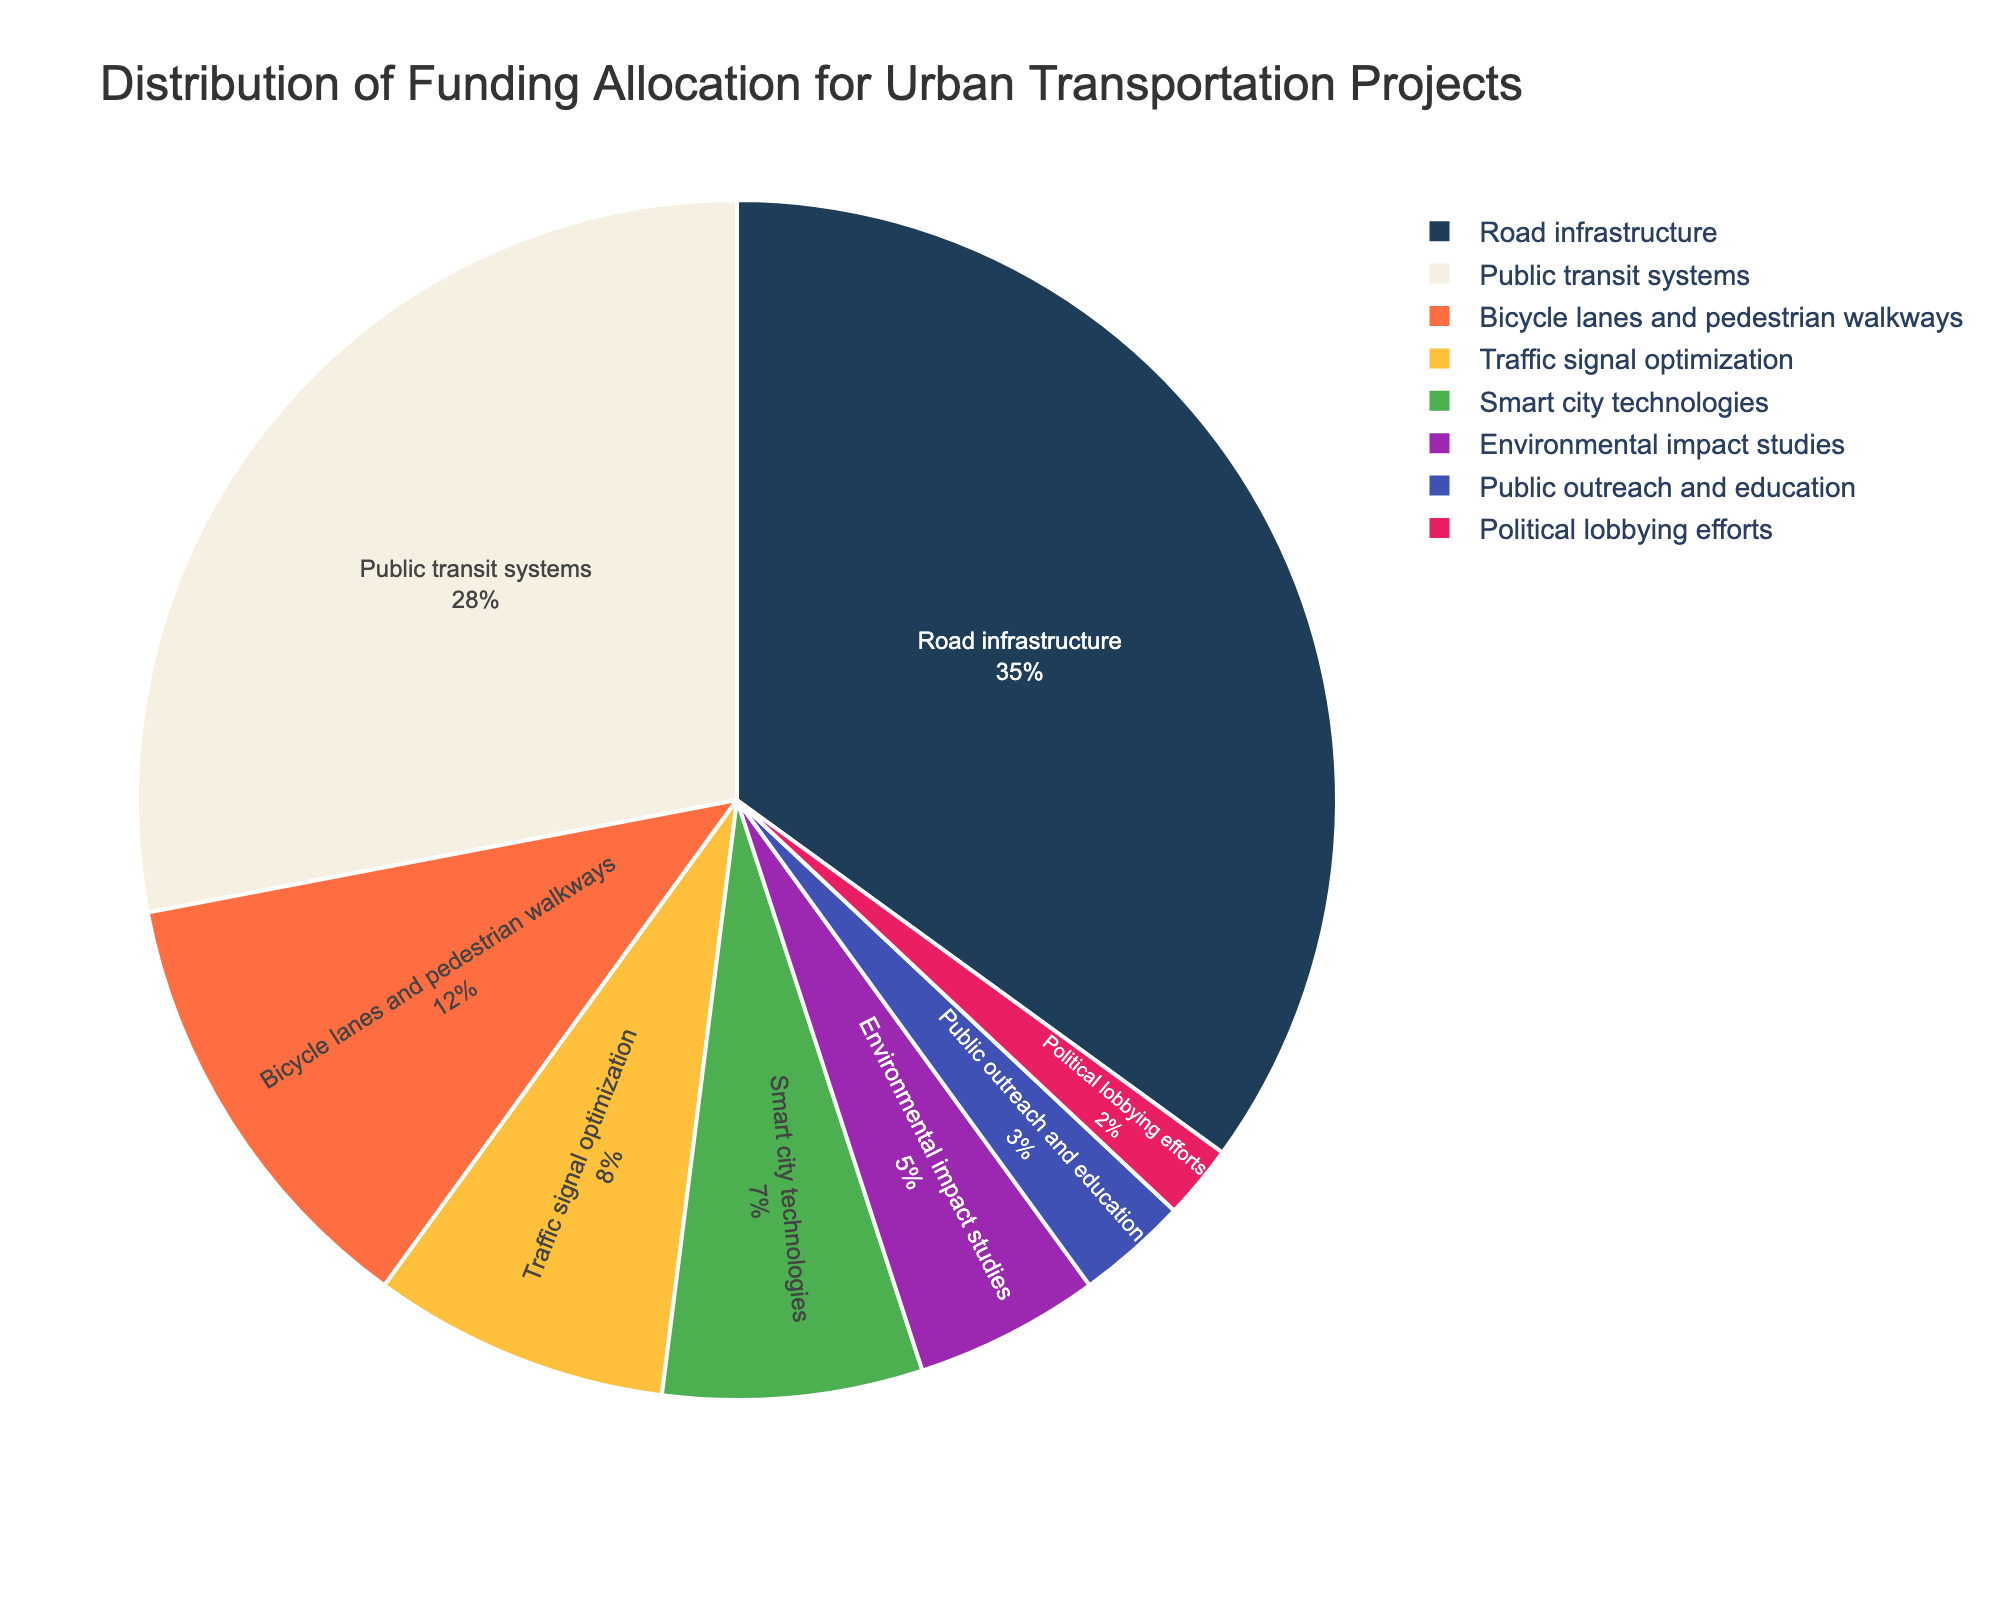What's the smallest category by percentage, and what is its percentage? The figure shows that Political lobbying efforts is the smallest segment by percentage. By looking at the chart, it is marked with 2%.
Answer: 2% Which category receives the highest percentage of funding? By examining the pie chart, Road infrastructure is the largest segment, which is evident as it takes up the most space on the chart and is labeled with the highest percentage.
Answer: Road infrastructure What is the combined percentage of funding for Bicycle lanes and pedestrian walkways and Traffic signal optimization? To determine the combined percentage, add the percentages of Bicycle lanes and pedestrian walkways (12%) and Traffic signal optimization (8%). 12% + 8% = 20%.
Answer: 20% How does the funding for Public transit systems compare to that of Smart city technologies? Public transit systems receive 28% funding, which is significantly greater than the 7% funding allocated to Smart city technologies.
Answer: Public transit systems > Smart city technologies What are the two categories with percentages closest to 10%? By examining the categories, Traffic signal optimization (8%) and Bicycle lanes and pedestrian walkways (12%) are the closest to 10%.
Answer: Traffic signal optimization and Bicycle lanes and pedestrian walkways Which category gets the least funding besides Political lobbying efforts, and what is the percentage? The second smallest segment after Political lobbying efforts (2%) is Public outreach and education, which receives 3%.
Answer: Public outreach and education, 3% Calculate the total percentage of funding allocated to Environmental impact studies and Public outreach and education combined with Smart city technologies. Add the percentages of Environmental impact studies (5%), Public outreach and education (3%), and Smart city technologies (7%). 5% + 3% + 7% = 15%.
Answer: 15% Visualize and estimate the difference in percentages between the largest and smallest categories. Visually identify the largest segment, Road infrastructure (35%), and the smallest segment, Political lobbying efforts (2%), then subtract their percentages. 35% - 2% = 33%.
Answer: 33% What is the difference in funding percentage between Environmental impact studies and Traffic signal optimization? Environmental impact studies receive 5% funding, and Traffic signal optimization receives 8% funding. Subtract 5% from 8% to find the difference. 8% - 5% = 3%.
Answer: 3% Among Smart city technologies, Public outreach and education, and Political lobbying efforts, which has the highest percentage? By comparing the segments, Smart city technologies has 7%, Public outreach and education has 3%, and Political lobbying efforts has 2%. Smart city technologies has the highest percentage among the three.
Answer: Smart city technologies 